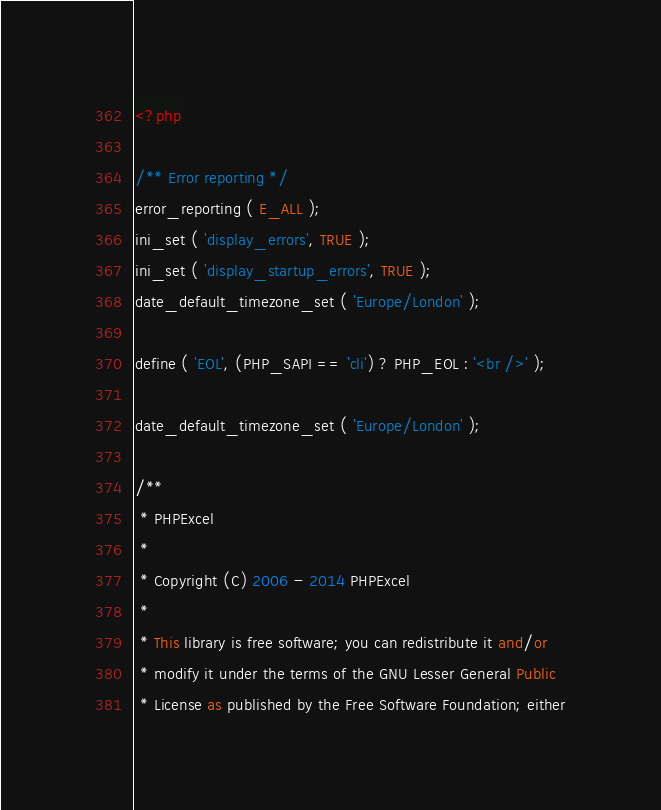<code> <loc_0><loc_0><loc_500><loc_500><_PHP_><?php

/** Error reporting */
error_reporting ( E_ALL );
ini_set ( 'display_errors', TRUE );
ini_set ( 'display_startup_errors', TRUE );
date_default_timezone_set ( 'Europe/London' );

define ( 'EOL', (PHP_SAPI == 'cli') ? PHP_EOL : '<br />' );

date_default_timezone_set ( 'Europe/London' );

/**
 * PHPExcel
 *
 * Copyright (C) 2006 - 2014 PHPExcel
 *
 * This library is free software; you can redistribute it and/or
 * modify it under the terms of the GNU Lesser General Public
 * License as published by the Free Software Foundation; either</code> 